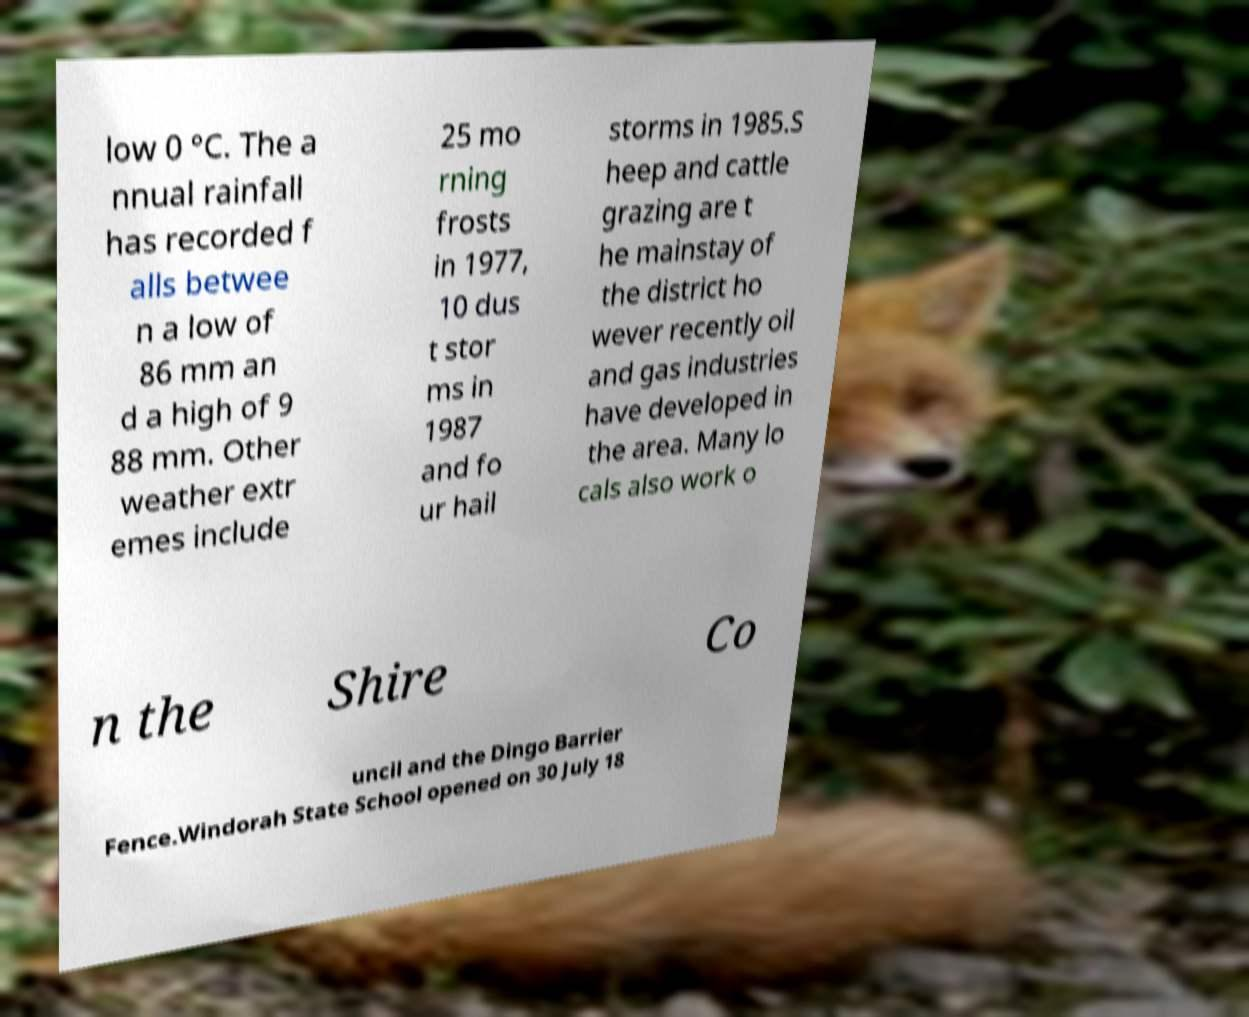Please identify and transcribe the text found in this image. low 0 °C. The a nnual rainfall has recorded f alls betwee n a low of 86 mm an d a high of 9 88 mm. Other weather extr emes include 25 mo rning frosts in 1977, 10 dus t stor ms in 1987 and fo ur hail storms in 1985.S heep and cattle grazing are t he mainstay of the district ho wever recently oil and gas industries have developed in the area. Many lo cals also work o n the Shire Co uncil and the Dingo Barrier Fence.Windorah State School opened on 30 July 18 